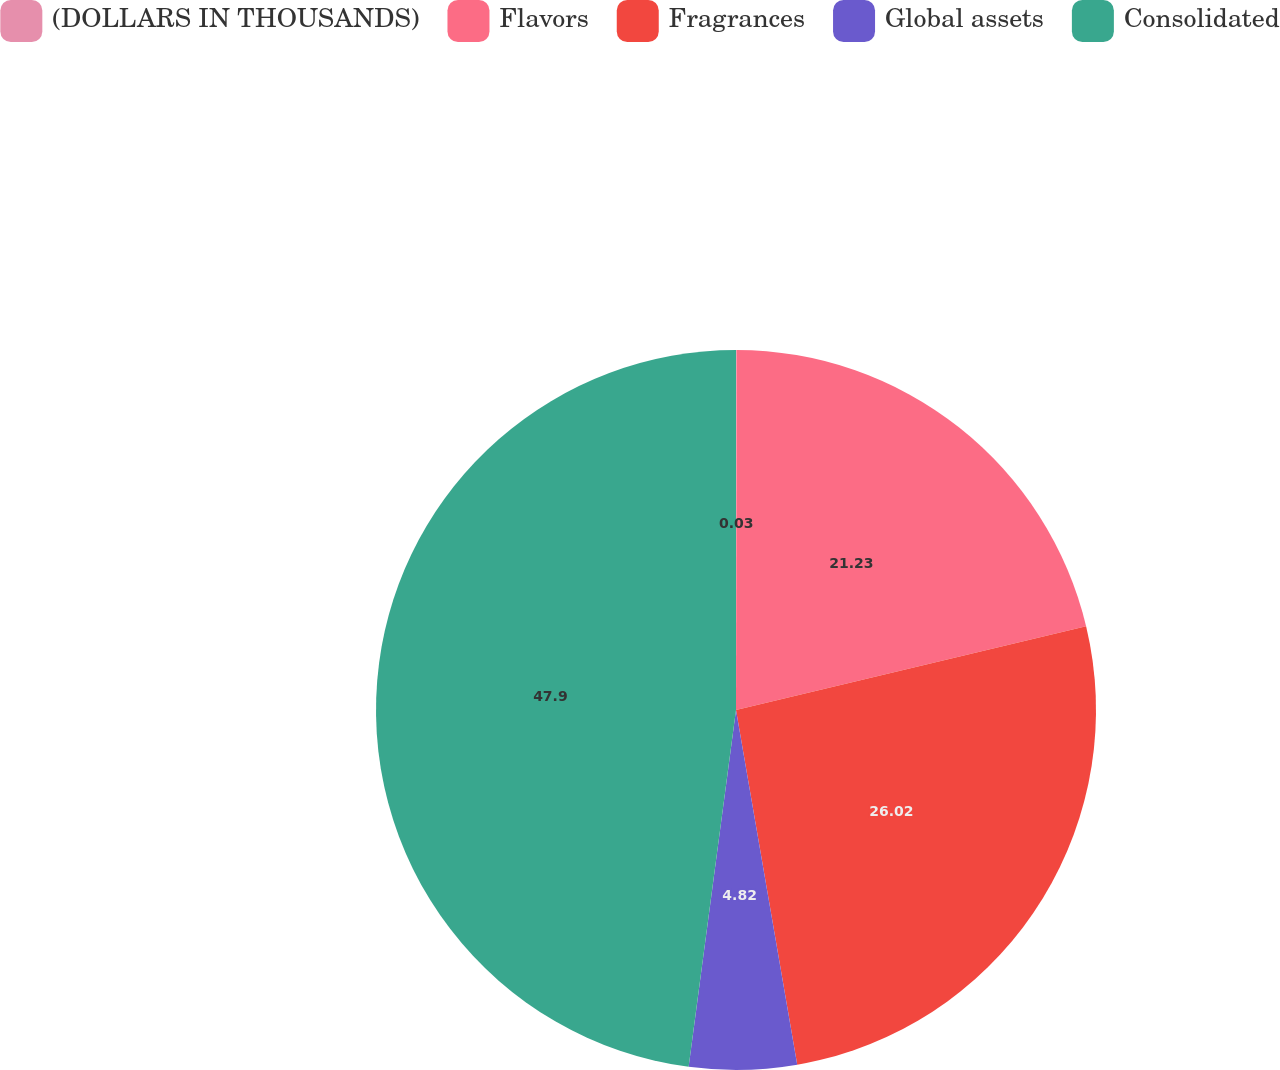<chart> <loc_0><loc_0><loc_500><loc_500><pie_chart><fcel>(DOLLARS IN THOUSANDS)<fcel>Flavors<fcel>Fragrances<fcel>Global assets<fcel>Consolidated<nl><fcel>0.03%<fcel>21.23%<fcel>26.02%<fcel>4.82%<fcel>47.9%<nl></chart> 